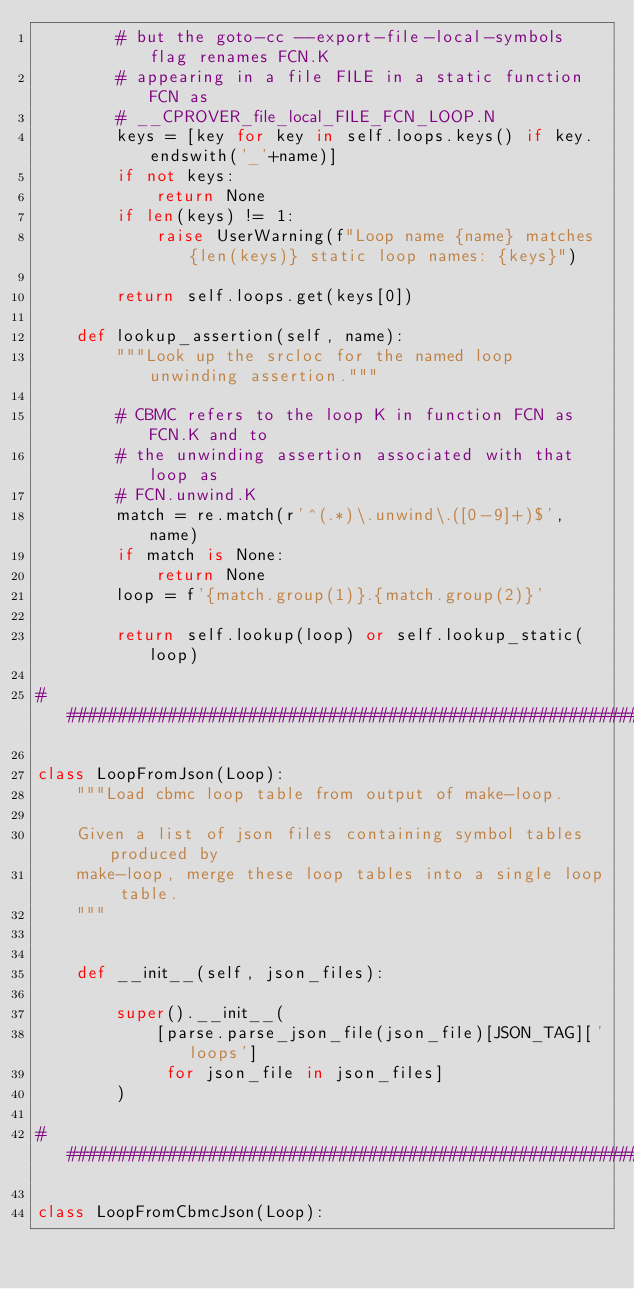Convert code to text. <code><loc_0><loc_0><loc_500><loc_500><_Python_>        # but the goto-cc --export-file-local-symbols flag renames FCN.K
        # appearing in a file FILE in a static function FCN as
        # __CPROVER_file_local_FILE_FCN_LOOP.N
        keys = [key for key in self.loops.keys() if key.endswith('_'+name)]
        if not keys:
            return None
        if len(keys) != 1:
            raise UserWarning(f"Loop name {name} matches {len(keys)} static loop names: {keys}")

        return self.loops.get(keys[0])

    def lookup_assertion(self, name):
        """Look up the srcloc for the named loop unwinding assertion."""

        # CBMC refers to the loop K in function FCN as FCN.K and to
        # the unwinding assertion associated with that loop as
        # FCN.unwind.K
        match = re.match(r'^(.*)\.unwind\.([0-9]+)$', name)
        if match is None:
            return None
        loop = f'{match.group(1)}.{match.group(2)}'

        return self.lookup(loop) or self.lookup_static(loop)

################################################################

class LoopFromJson(Loop):
    """Load cbmc loop table from output of make-loop.

    Given a list of json files containing symbol tables produced by
    make-loop, merge these loop tables into a single loop table.
    """


    def __init__(self, json_files):

        super().__init__(
            [parse.parse_json_file(json_file)[JSON_TAG]['loops']
             for json_file in json_files]
        )

################################################################

class LoopFromCbmcJson(Loop):</code> 